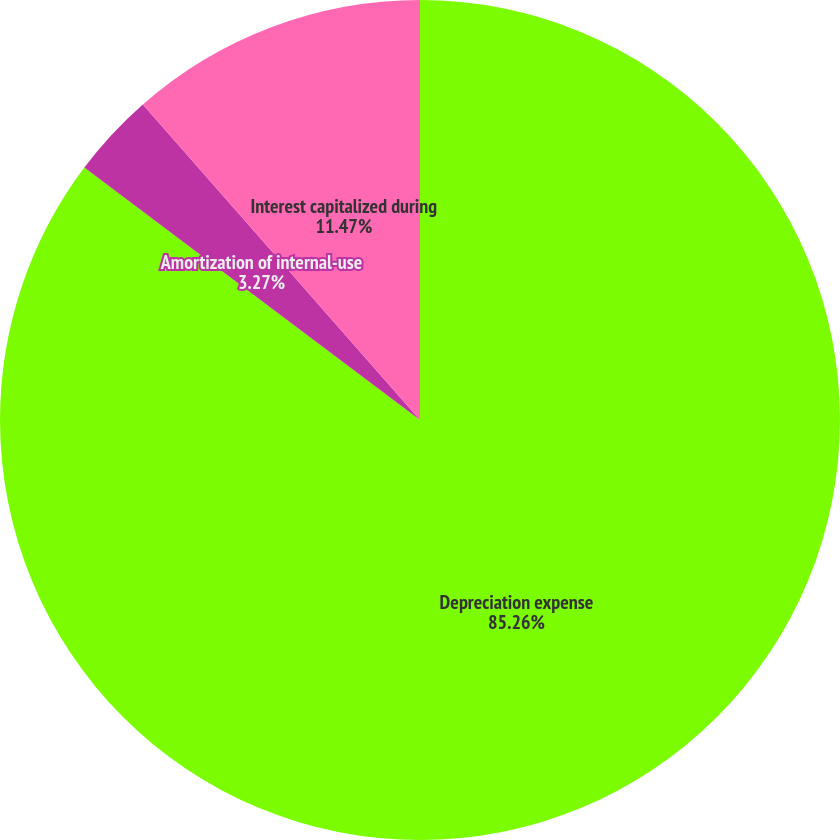Convert chart to OTSL. <chart><loc_0><loc_0><loc_500><loc_500><pie_chart><fcel>Depreciation expense<fcel>Amortization of internal-use<fcel>Interest capitalized during<nl><fcel>85.26%<fcel>3.27%<fcel>11.47%<nl></chart> 